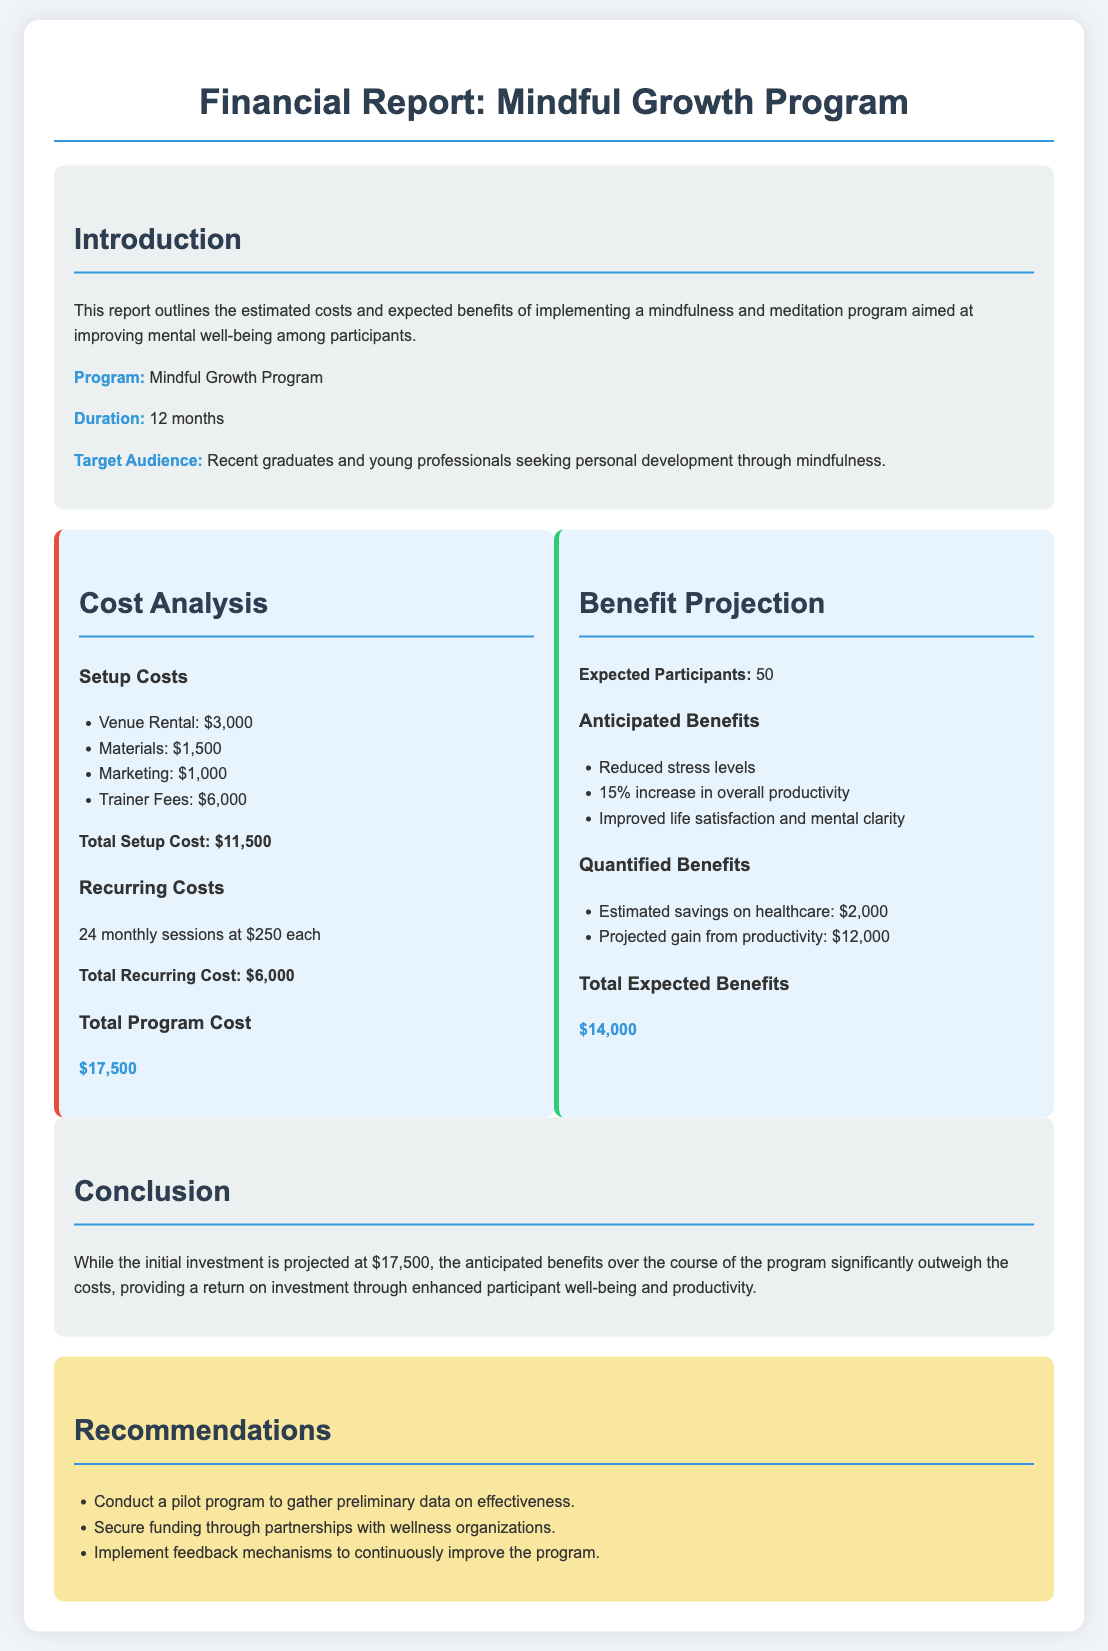What is the total setup cost? The total setup cost is outlined in the document under the cost analysis section, which totals $11,500.
Answer: $11,500 What is the expected number of participants? The expected number of participants is mentioned under the benefits projection section, which states 50 participants.
Answer: 50 What is the total program cost? The total program cost is listed in the cost analysis section and is highlighted as $17,500.
Answer: $17,500 What percentage increase in productivity is projected? The anticipated benefits section specifies a 15% increase in overall productivity.
Answer: 15% What is the estimated savings on healthcare? The quantified benefits list the estimated savings on healthcare as $2,000.
Answer: $2,000 What type of program is being analyzed? The document introduces the program as the "Mindful Growth Program."
Answer: Mindful Growth Program How long is the duration of the program? The duration of the program is detailed in the introduction, which indicates 12 months.
Answer: 12 months What should be conducted to gather preliminary data? The recommendations section advises conducting a pilot program for this purpose.
Answer: Pilot program 